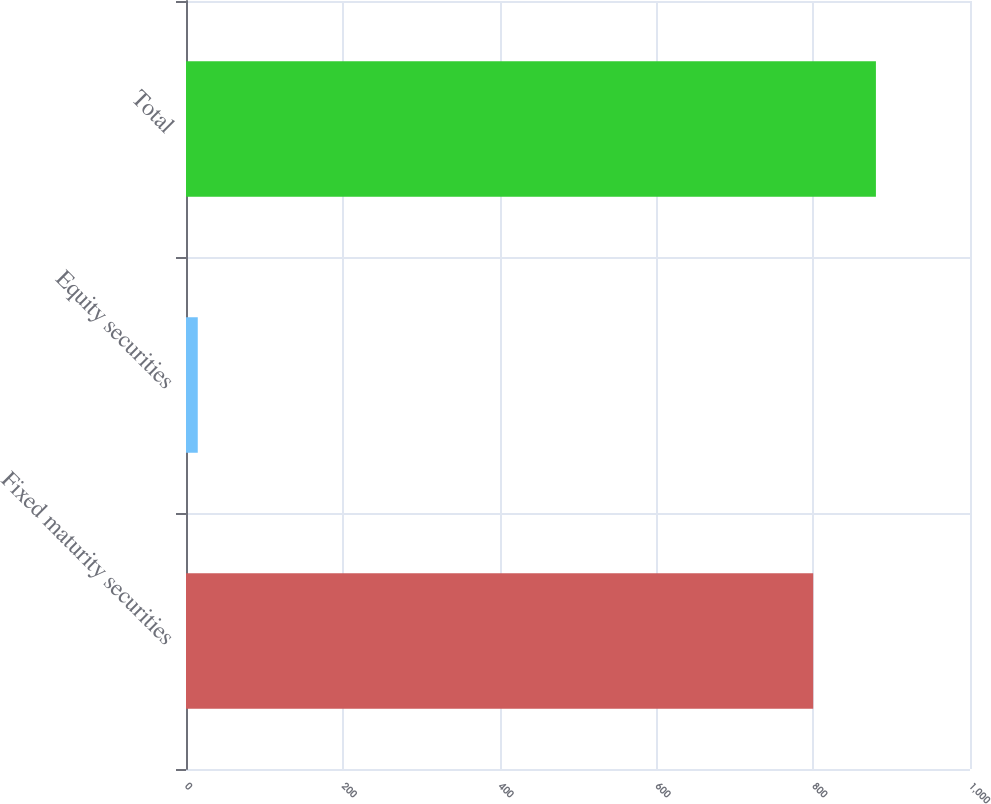Convert chart. <chart><loc_0><loc_0><loc_500><loc_500><bar_chart><fcel>Fixed maturity securities<fcel>Equity securities<fcel>Total<nl><fcel>800<fcel>15<fcel>880<nl></chart> 